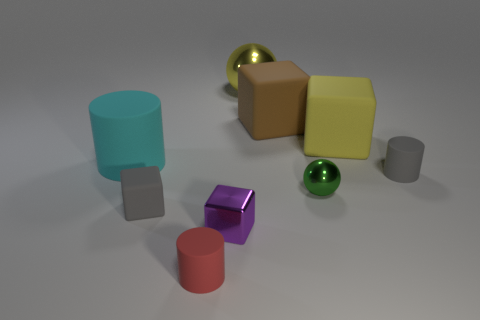Subtract 1 cubes. How many cubes are left? 3 Add 1 small balls. How many objects exist? 10 Subtract all cylinders. How many objects are left? 6 Subtract 0 brown balls. How many objects are left? 9 Subtract all cyan cylinders. Subtract all green metallic objects. How many objects are left? 7 Add 7 gray matte things. How many gray matte things are left? 9 Add 7 green metal balls. How many green metal balls exist? 8 